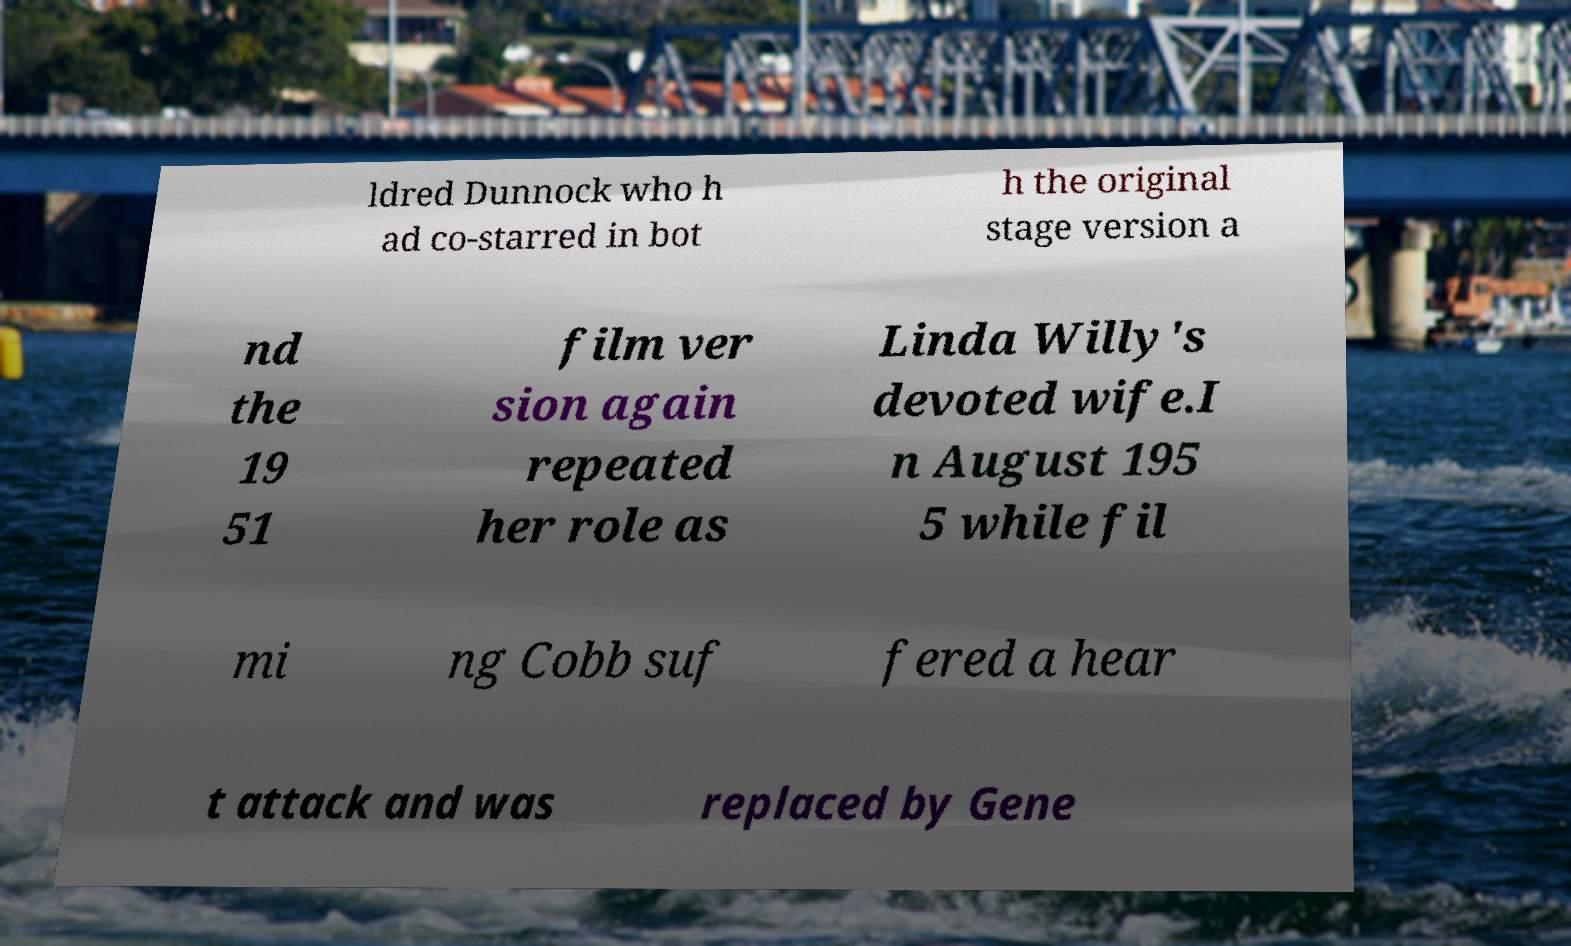Please identify and transcribe the text found in this image. ldred Dunnock who h ad co-starred in bot h the original stage version a nd the 19 51 film ver sion again repeated her role as Linda Willy's devoted wife.I n August 195 5 while fil mi ng Cobb suf fered a hear t attack and was replaced by Gene 